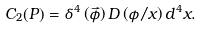Convert formula to latex. <formula><loc_0><loc_0><loc_500><loc_500>C _ { 2 } ( P ) = \delta ^ { 4 } \left ( \vec { \phi } \right ) D \left ( \phi / x \right ) d ^ { 4 } x .</formula> 